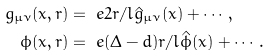Convert formula to latex. <formula><loc_0><loc_0><loc_500><loc_500>g _ { \mu \nu } ( x , r ) & = \ e { 2 r / l } \hat { g } _ { \mu \nu } ( x ) + \cdots , \\ \phi ( x , r ) & = \ e { ( \Delta - d ) r / l } \hat { \phi } ( x ) + \cdots .</formula> 